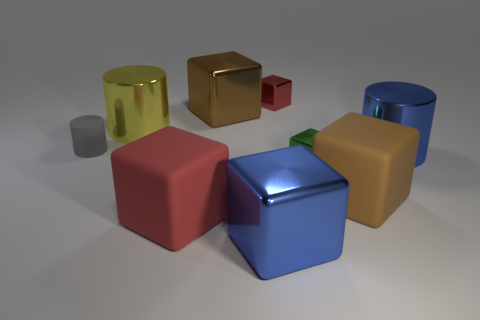There is a small rubber cylinder; is its color the same as the cylinder in front of the tiny rubber thing?
Provide a succinct answer. No. There is a object that is both in front of the yellow object and to the left of the red matte object; what color is it?
Make the answer very short. Gray. What number of other things are there of the same material as the blue block
Ensure brevity in your answer.  5. Is the number of large brown matte objects less than the number of small blue rubber blocks?
Provide a short and direct response. No. Is the material of the gray object the same as the brown cube behind the big blue cylinder?
Provide a succinct answer. No. What shape is the large matte object left of the big brown metal cube?
Your answer should be very brief. Cube. Is there any other thing that is the same color as the matte cylinder?
Make the answer very short. No. Are there fewer large cubes that are in front of the large blue block than small gray matte objects?
Offer a terse response. Yes. What number of green balls have the same size as the yellow cylinder?
Give a very brief answer. 0. There is a big blue shiny thing in front of the brown object that is in front of the brown cube behind the small green metal block; what shape is it?
Your answer should be very brief. Cube. 